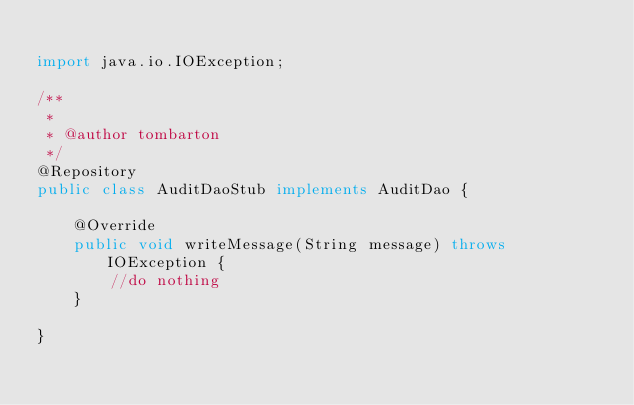Convert code to text. <code><loc_0><loc_0><loc_500><loc_500><_Java_>
import java.io.IOException;

/**
 *
 * @author tombarton
 */
@Repository
public class AuditDaoStub implements AuditDao {

    @Override
    public void writeMessage(String message) throws IOException {
        //do nothing
    }
    
}
</code> 